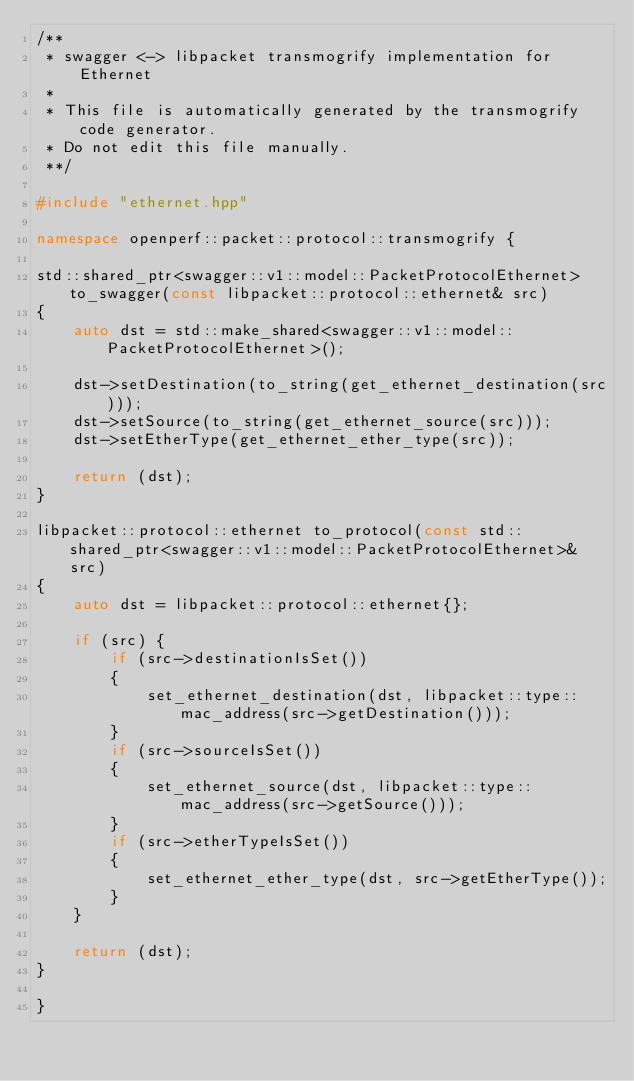Convert code to text. <code><loc_0><loc_0><loc_500><loc_500><_C++_>/**
 * swagger <-> libpacket transmogrify implementation for Ethernet
 *
 * This file is automatically generated by the transmogrify code generator.
 * Do not edit this file manually.
 **/

#include "ethernet.hpp"

namespace openperf::packet::protocol::transmogrify {

std::shared_ptr<swagger::v1::model::PacketProtocolEthernet> to_swagger(const libpacket::protocol::ethernet& src)
{
    auto dst = std::make_shared<swagger::v1::model::PacketProtocolEthernet>();

    dst->setDestination(to_string(get_ethernet_destination(src)));
    dst->setSource(to_string(get_ethernet_source(src)));
    dst->setEtherType(get_ethernet_ether_type(src));

    return (dst);
}

libpacket::protocol::ethernet to_protocol(const std::shared_ptr<swagger::v1::model::PacketProtocolEthernet>& src)
{
    auto dst = libpacket::protocol::ethernet{};

    if (src) {
        if (src->destinationIsSet())
        {
            set_ethernet_destination(dst, libpacket::type::mac_address(src->getDestination()));
        }
        if (src->sourceIsSet())
        {
            set_ethernet_source(dst, libpacket::type::mac_address(src->getSource()));
        }
        if (src->etherTypeIsSet())
        {
            set_ethernet_ether_type(dst, src->getEtherType());
        }
    }

    return (dst);
}

}
</code> 